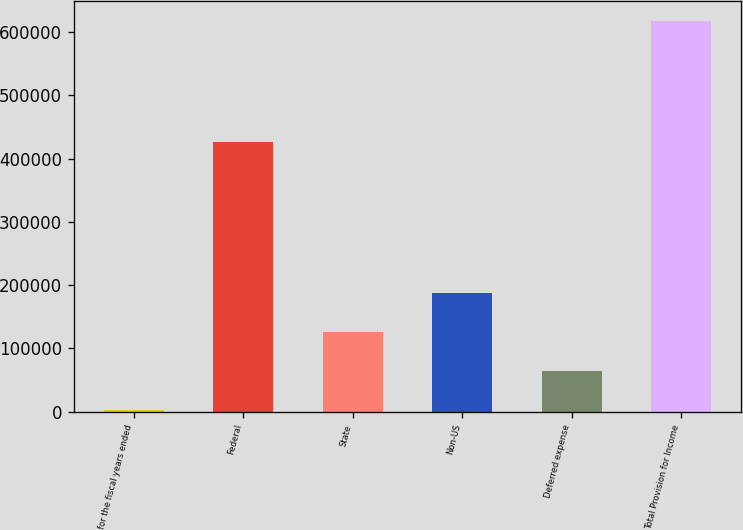<chart> <loc_0><loc_0><loc_500><loc_500><bar_chart><fcel>for the fiscal years ended<fcel>Federal<fcel>State<fcel>Non-US<fcel>Deferred expense<fcel>Total Provision for Income<nl><fcel>2010<fcel>426470<fcel>125270<fcel>186901<fcel>63640.2<fcel>618312<nl></chart> 